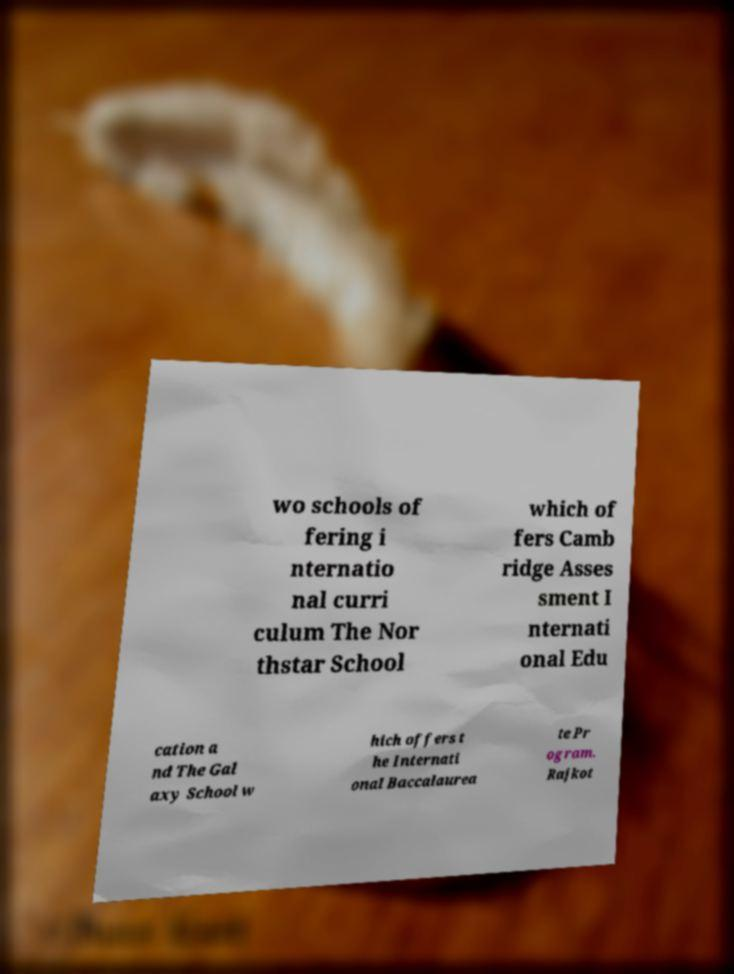For documentation purposes, I need the text within this image transcribed. Could you provide that? wo schools of fering i nternatio nal curri culum The Nor thstar School which of fers Camb ridge Asses sment I nternati onal Edu cation a nd The Gal axy School w hich offers t he Internati onal Baccalaurea te Pr ogram. Rajkot 